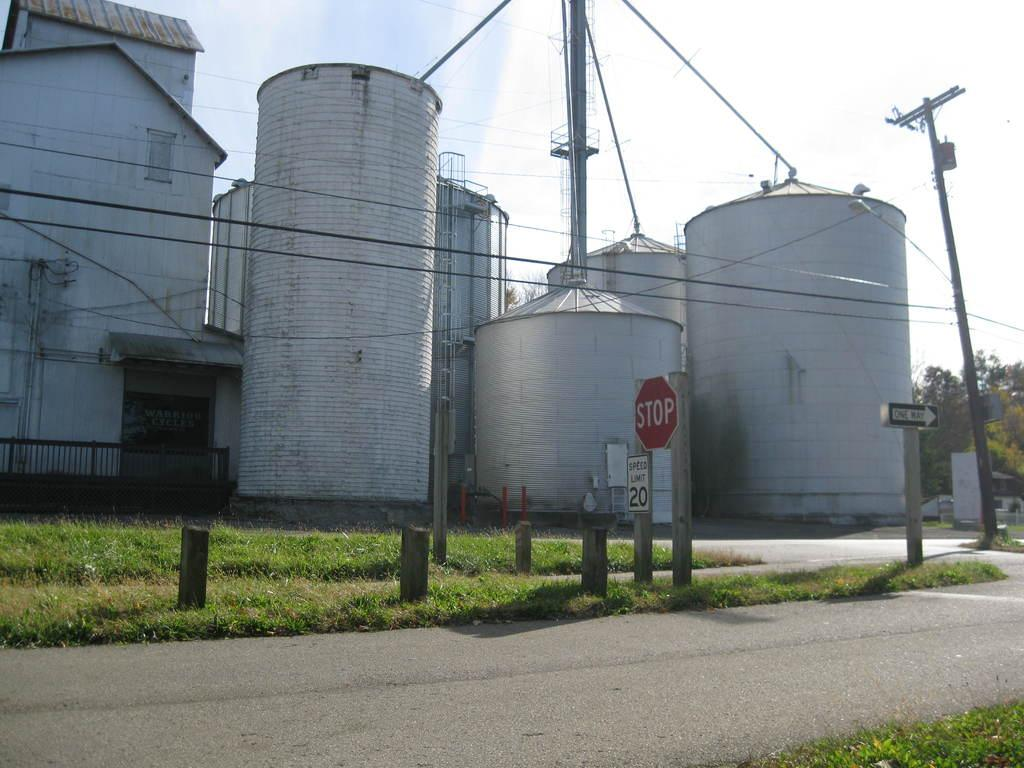What can be seen in the sky in the image? The sky is visible in the image, and there are clouds present. What type of vegetation is visible in the image? Trees are present in the image. What type of structures can be seen in the image? There are buildings and cylindrical shaped structures visible in the image. What other objects are present in the image? Poles, sign boards, a fence, and a road are present in the image. What is the ground surface like in the image? Grass is visible in the image. How many rabbits can be seen hopping on the linen in the image? There are no rabbits or linen present in the image. 